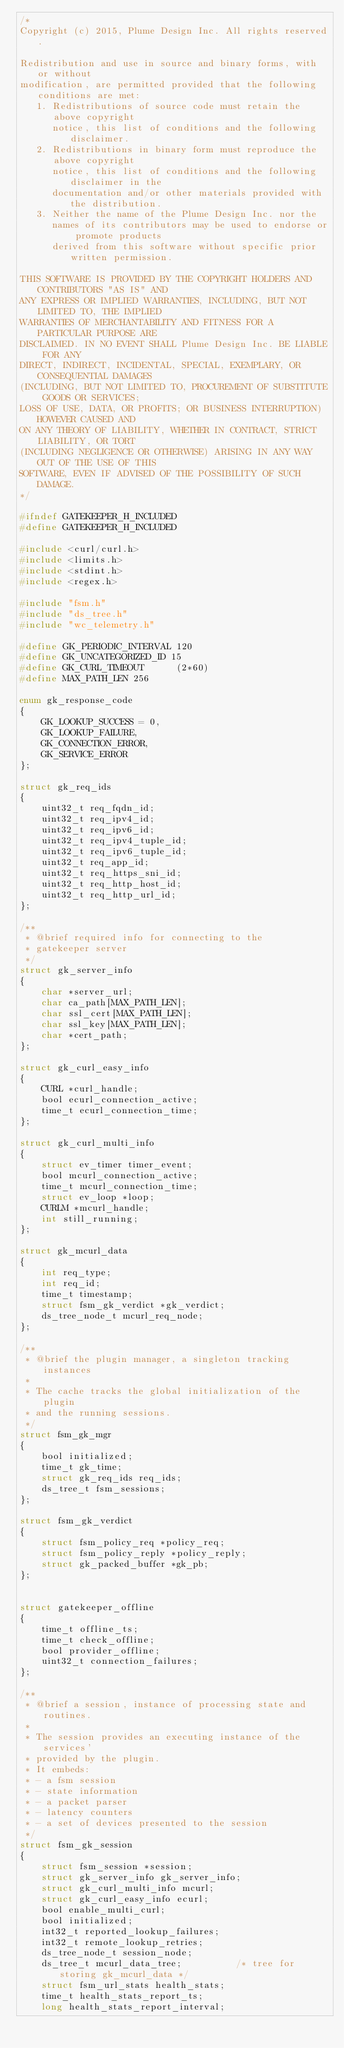<code> <loc_0><loc_0><loc_500><loc_500><_C_>/*
Copyright (c) 2015, Plume Design Inc. All rights reserved.

Redistribution and use in source and binary forms, with or without
modification, are permitted provided that the following conditions are met:
   1. Redistributions of source code must retain the above copyright
      notice, this list of conditions and the following disclaimer.
   2. Redistributions in binary form must reproduce the above copyright
      notice, this list of conditions and the following disclaimer in the
      documentation and/or other materials provided with the distribution.
   3. Neither the name of the Plume Design Inc. nor the
      names of its contributors may be used to endorse or promote products
      derived from this software without specific prior written permission.

THIS SOFTWARE IS PROVIDED BY THE COPYRIGHT HOLDERS AND CONTRIBUTORS "AS IS" AND
ANY EXPRESS OR IMPLIED WARRANTIES, INCLUDING, BUT NOT LIMITED TO, THE IMPLIED
WARRANTIES OF MERCHANTABILITY AND FITNESS FOR A PARTICULAR PURPOSE ARE
DISCLAIMED. IN NO EVENT SHALL Plume Design Inc. BE LIABLE FOR ANY
DIRECT, INDIRECT, INCIDENTAL, SPECIAL, EXEMPLARY, OR CONSEQUENTIAL DAMAGES
(INCLUDING, BUT NOT LIMITED TO, PROCUREMENT OF SUBSTITUTE GOODS OR SERVICES;
LOSS OF USE, DATA, OR PROFITS; OR BUSINESS INTERRUPTION) HOWEVER CAUSED AND
ON ANY THEORY OF LIABILITY, WHETHER IN CONTRACT, STRICT LIABILITY, OR TORT
(INCLUDING NEGLIGENCE OR OTHERWISE) ARISING IN ANY WAY OUT OF THE USE OF THIS
SOFTWARE, EVEN IF ADVISED OF THE POSSIBILITY OF SUCH DAMAGE.
*/

#ifndef GATEKEEPER_H_INCLUDED
#define GATEKEEPER_H_INCLUDED

#include <curl/curl.h>
#include <limits.h>
#include <stdint.h>
#include <regex.h>

#include "fsm.h"
#include "ds_tree.h"
#include "wc_telemetry.h"

#define GK_PERIODIC_INTERVAL 120
#define GK_UNCATEGORIZED_ID 15
#define GK_CURL_TIMEOUT      (2*60)
#define MAX_PATH_LEN 256

enum gk_response_code
{
    GK_LOOKUP_SUCCESS = 0,
    GK_LOOKUP_FAILURE,
    GK_CONNECTION_ERROR,
    GK_SERVICE_ERROR
};

struct gk_req_ids
{
    uint32_t req_fqdn_id;
    uint32_t req_ipv4_id;
    uint32_t req_ipv6_id;
    uint32_t req_ipv4_tuple_id;
    uint32_t req_ipv6_tuple_id;
    uint32_t req_app_id;
    uint32_t req_https_sni_id;
    uint32_t req_http_host_id;
    uint32_t req_http_url_id;
};

/**
 * @brief required info for connecting to the
 * gatekeeper server
 */
struct gk_server_info
{
    char *server_url;
    char ca_path[MAX_PATH_LEN];
    char ssl_cert[MAX_PATH_LEN];
    char ssl_key[MAX_PATH_LEN];
    char *cert_path;
};

struct gk_curl_easy_info
{
    CURL *curl_handle;
    bool ecurl_connection_active;
    time_t ecurl_connection_time;
};

struct gk_curl_multi_info
{
    struct ev_timer timer_event;
    bool mcurl_connection_active;
    time_t mcurl_connection_time;
    struct ev_loop *loop;
    CURLM *mcurl_handle;
    int still_running;
};

struct gk_mcurl_data
{
    int req_type;
    int req_id;
    time_t timestamp;
    struct fsm_gk_verdict *gk_verdict;
    ds_tree_node_t mcurl_req_node;
};

/**
 * @brief the plugin manager, a singleton tracking instances
 *
 * The cache tracks the global initialization of the plugin
 * and the running sessions.
 */
struct fsm_gk_mgr
{
    bool initialized;
    time_t gk_time;
    struct gk_req_ids req_ids;
    ds_tree_t fsm_sessions;
};

struct fsm_gk_verdict
{
    struct fsm_policy_req *policy_req;
    struct fsm_policy_reply *policy_reply;
    struct gk_packed_buffer *gk_pb;
};


struct gatekeeper_offline
{
    time_t offline_ts;
    time_t check_offline;
    bool provider_offline;
    uint32_t connection_failures;
};

/**
 * @brief a session, instance of processing state and routines.
 *
 * The session provides an executing instance of the services'
 * provided by the plugin.
 * It embeds:
 * - a fsm session
 * - state information
 * - a packet parser
 * - latency counters
 * - a set of devices presented to the session
 */
struct fsm_gk_session
{
    struct fsm_session *session;
    struct gk_server_info gk_server_info;
    struct gk_curl_multi_info mcurl;
    struct gk_curl_easy_info ecurl;
    bool enable_multi_curl;
    bool initialized;
    int32_t reported_lookup_failures;
    int32_t remote_lookup_retries;
    ds_tree_node_t session_node;
    ds_tree_t mcurl_data_tree;          /* tree for storing gk_mcurl_data */
    struct fsm_url_stats health_stats;
    time_t health_stats_report_ts;
    long health_stats_report_interval;</code> 